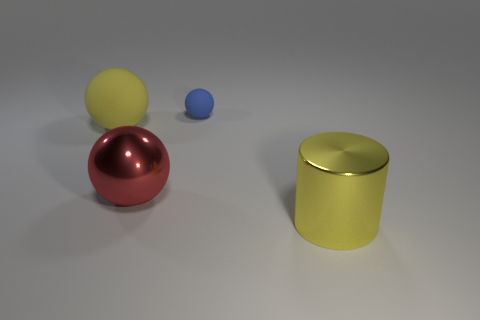The thing that is both right of the red metal object and in front of the big yellow matte ball is what color?
Your response must be concise. Yellow. How many objects are things that are behind the metal cylinder or metallic spheres?
Keep it short and to the point. 3. What number of other objects are there of the same color as the tiny rubber ball?
Your answer should be compact. 0. Is the number of tiny blue balls in front of the tiny blue object the same as the number of large metal spheres?
Your answer should be very brief. No. There is a yellow thing that is right of the yellow thing that is to the left of the yellow cylinder; what number of blue balls are right of it?
Your response must be concise. 0. Is there anything else that has the same size as the yellow cylinder?
Your answer should be very brief. Yes. There is a red sphere; does it have the same size as the yellow thing that is to the left of the blue matte thing?
Provide a short and direct response. Yes. How many large yellow matte cylinders are there?
Offer a terse response. 0. Does the yellow thing that is left of the big yellow cylinder have the same size as the shiny object behind the yellow metal cylinder?
Your response must be concise. Yes. There is a small matte object that is the same shape as the large red metallic object; what color is it?
Ensure brevity in your answer.  Blue. 